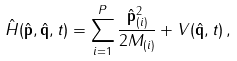Convert formula to latex. <formula><loc_0><loc_0><loc_500><loc_500>\hat { H } ( \hat { \mathbf p } , \hat { \mathbf q } , t ) = \sum _ { i = 1 } ^ { P } \frac { \hat { \mathbf p } _ { ( i ) } ^ { 2 } } { 2 M _ { ( i ) } } + V ( \hat { \mathbf q } , t ) \, ,</formula> 